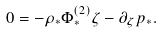<formula> <loc_0><loc_0><loc_500><loc_500>0 = - \rho _ { * } \Phi ^ { ( 2 ) } _ { * } \zeta - \partial _ { \zeta } p _ { * } .</formula> 